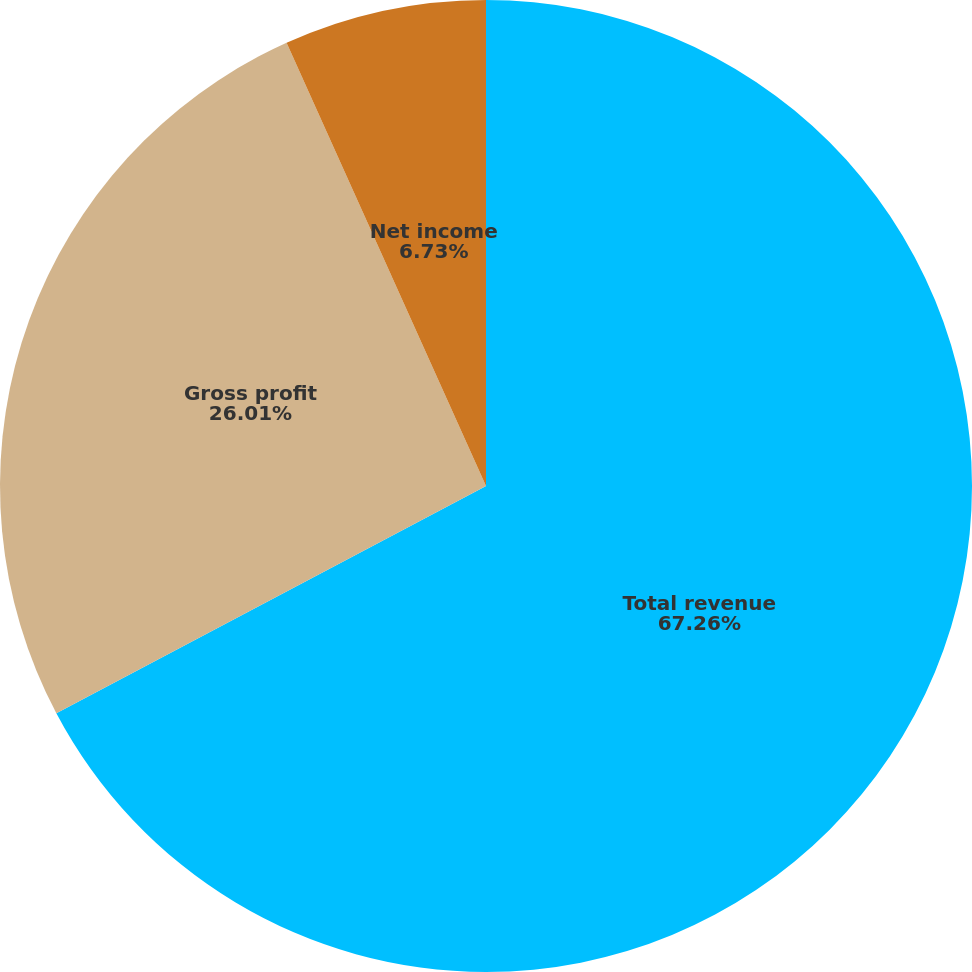Convert chart to OTSL. <chart><loc_0><loc_0><loc_500><loc_500><pie_chart><fcel>Total revenue<fcel>Gross profit<fcel>Net income<fcel>Diluted net income per common<nl><fcel>67.26%<fcel>26.01%<fcel>6.73%<fcel>0.0%<nl></chart> 